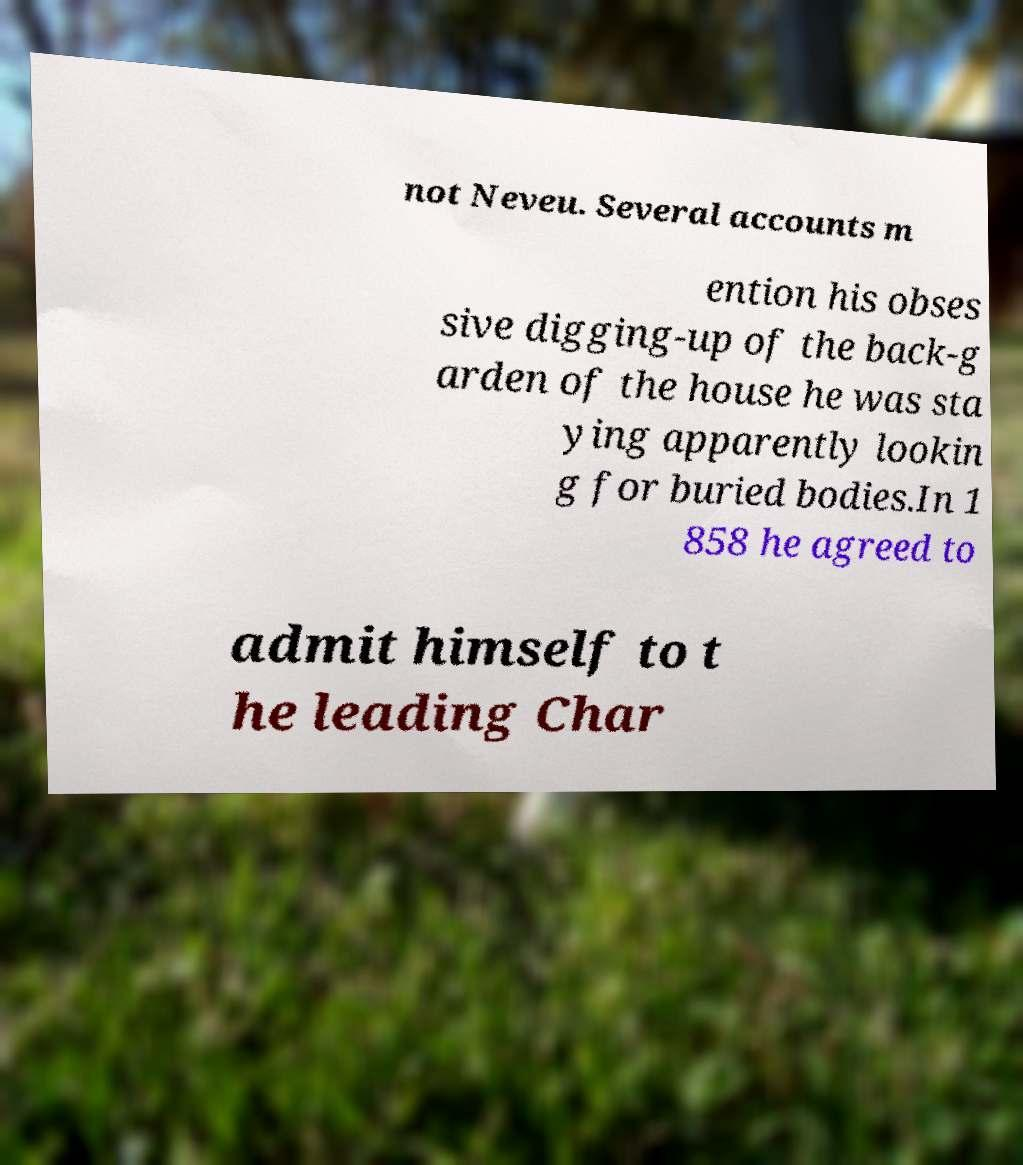Please identify and transcribe the text found in this image. not Neveu. Several accounts m ention his obses sive digging-up of the back-g arden of the house he was sta ying apparently lookin g for buried bodies.In 1 858 he agreed to admit himself to t he leading Char 